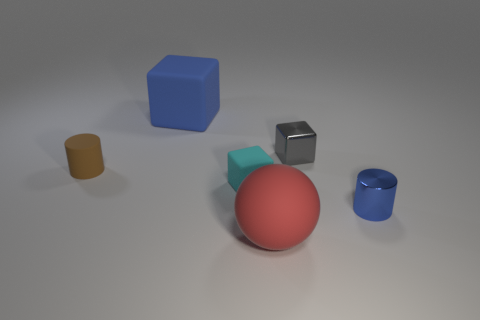What number of big matte things are the same color as the shiny cylinder?
Your answer should be very brief. 1. How many other objects are the same shape as the small gray metal object?
Provide a succinct answer. 2. Is the shape of the large matte object that is behind the small metal cube the same as the blue thing right of the large cube?
Offer a terse response. No. What number of cylinders are right of the big matte object that is behind the small matte thing that is on the right side of the blue cube?
Your answer should be compact. 1. What is the color of the big matte block?
Keep it short and to the point. Blue. How many other things are there of the same size as the matte sphere?
Offer a terse response. 1. There is a gray object that is the same shape as the large blue object; what is its material?
Keep it short and to the point. Metal. What is the material of the large object behind the big object that is in front of the matte cube that is to the right of the big blue thing?
Make the answer very short. Rubber. There is a blue thing that is made of the same material as the gray object; what is its size?
Your response must be concise. Small. Is there anything else of the same color as the shiny cylinder?
Your answer should be compact. Yes. 